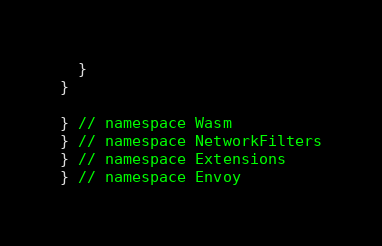<code> <loc_0><loc_0><loc_500><loc_500><_C++_>  }
}

} // namespace Wasm
} // namespace NetworkFilters
} // namespace Extensions
} // namespace Envoy
</code> 